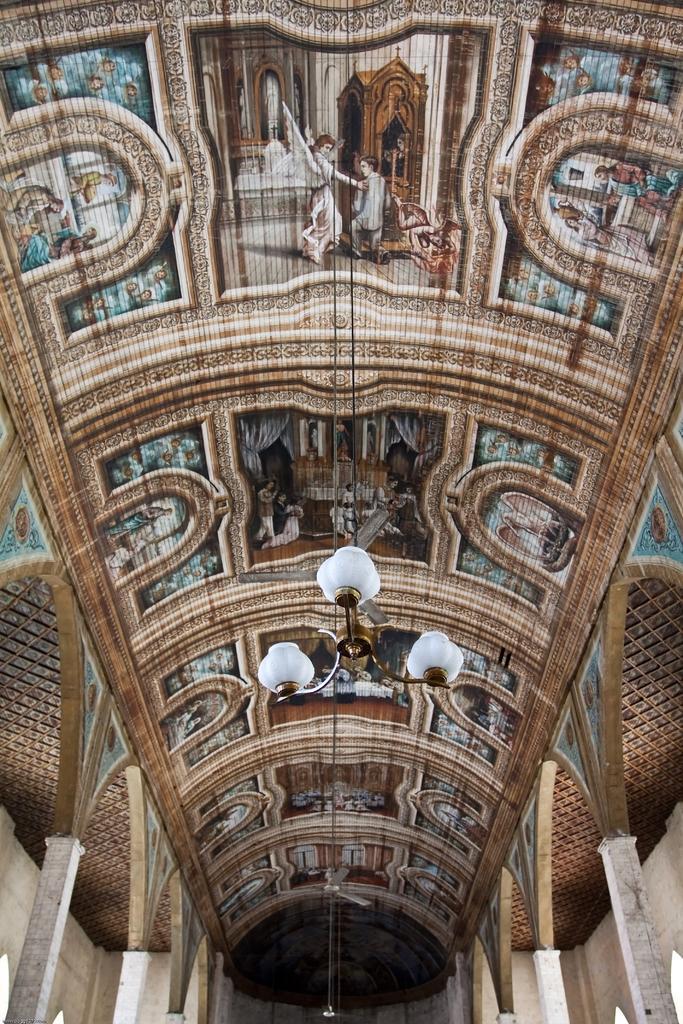How would you summarize this image in a sentence or two? In the image we can see a roof, on the roof there are some paintings and light. 